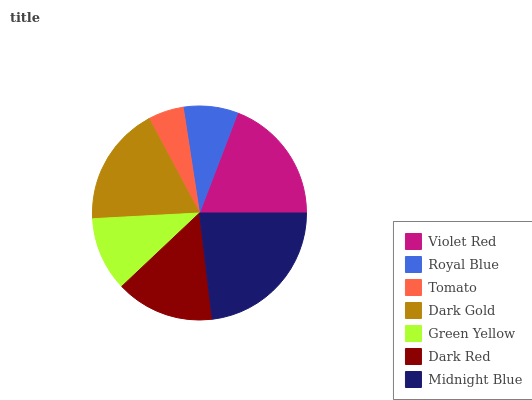Is Tomato the minimum?
Answer yes or no. Yes. Is Midnight Blue the maximum?
Answer yes or no. Yes. Is Royal Blue the minimum?
Answer yes or no. No. Is Royal Blue the maximum?
Answer yes or no. No. Is Violet Red greater than Royal Blue?
Answer yes or no. Yes. Is Royal Blue less than Violet Red?
Answer yes or no. Yes. Is Royal Blue greater than Violet Red?
Answer yes or no. No. Is Violet Red less than Royal Blue?
Answer yes or no. No. Is Dark Red the high median?
Answer yes or no. Yes. Is Dark Red the low median?
Answer yes or no. Yes. Is Dark Gold the high median?
Answer yes or no. No. Is Tomato the low median?
Answer yes or no. No. 